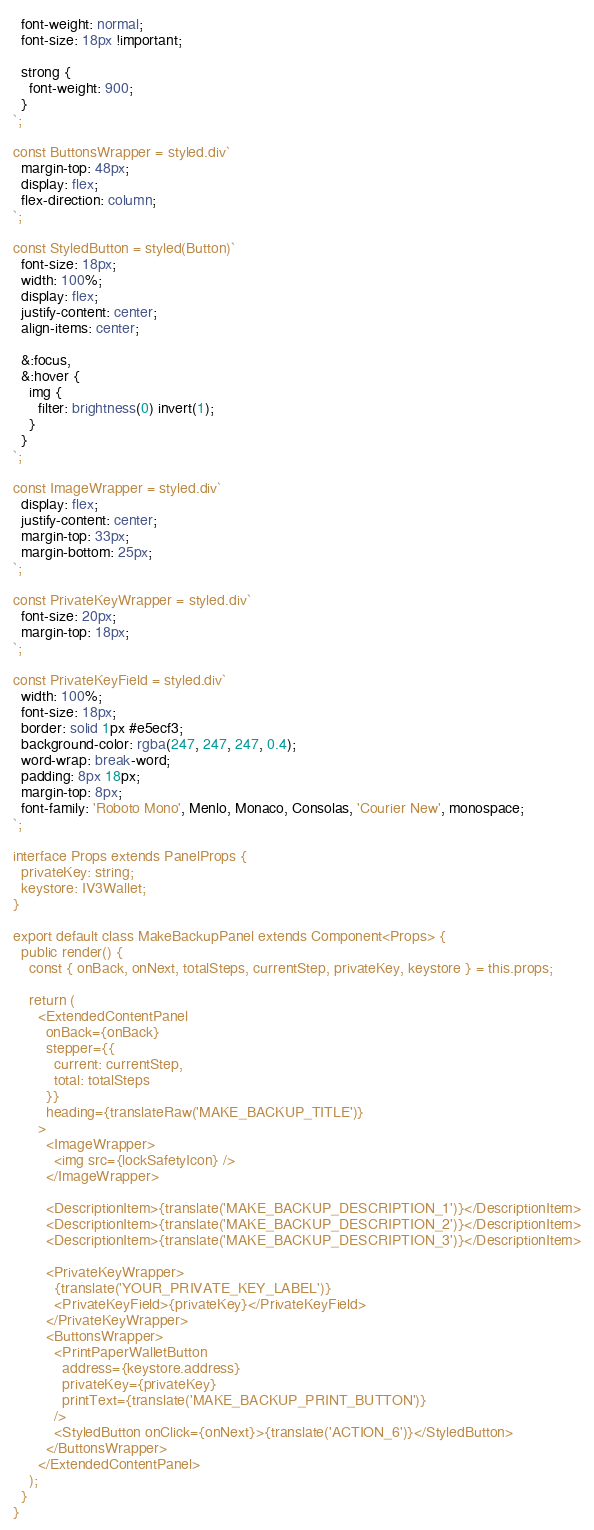Convert code to text. <code><loc_0><loc_0><loc_500><loc_500><_TypeScript_>  font-weight: normal;
  font-size: 18px !important;

  strong {
    font-weight: 900;
  }
`;

const ButtonsWrapper = styled.div`
  margin-top: 48px;
  display: flex;
  flex-direction: column;
`;

const StyledButton = styled(Button)`
  font-size: 18px;
  width: 100%;
  display: flex;
  justify-content: center;
  align-items: center;

  &:focus,
  &:hover {
    img {
      filter: brightness(0) invert(1);
    }
  }
`;

const ImageWrapper = styled.div`
  display: flex;
  justify-content: center;
  margin-top: 33px;
  margin-bottom: 25px;
`;

const PrivateKeyWrapper = styled.div`
  font-size: 20px;
  margin-top: 18px;
`;

const PrivateKeyField = styled.div`
  width: 100%;
  font-size: 18px;
  border: solid 1px #e5ecf3;
  background-color: rgba(247, 247, 247, 0.4);
  word-wrap: break-word;
  padding: 8px 18px;
  margin-top: 8px;
  font-family: 'Roboto Mono', Menlo, Monaco, Consolas, 'Courier New', monospace;
`;

interface Props extends PanelProps {
  privateKey: string;
  keystore: IV3Wallet;
}

export default class MakeBackupPanel extends Component<Props> {
  public render() {
    const { onBack, onNext, totalSteps, currentStep, privateKey, keystore } = this.props;

    return (
      <ExtendedContentPanel
        onBack={onBack}
        stepper={{
          current: currentStep,
          total: totalSteps
        }}
        heading={translateRaw('MAKE_BACKUP_TITLE')}
      >
        <ImageWrapper>
          <img src={lockSafetyIcon} />
        </ImageWrapper>

        <DescriptionItem>{translate('MAKE_BACKUP_DESCRIPTION_1')}</DescriptionItem>
        <DescriptionItem>{translate('MAKE_BACKUP_DESCRIPTION_2')}</DescriptionItem>
        <DescriptionItem>{translate('MAKE_BACKUP_DESCRIPTION_3')}</DescriptionItem>

        <PrivateKeyWrapper>
          {translate('YOUR_PRIVATE_KEY_LABEL')}
          <PrivateKeyField>{privateKey}</PrivateKeyField>
        </PrivateKeyWrapper>
        <ButtonsWrapper>
          <PrintPaperWalletButton
            address={keystore.address}
            privateKey={privateKey}
            printText={translate('MAKE_BACKUP_PRINT_BUTTON')}
          />
          <StyledButton onClick={onNext}>{translate('ACTION_6')}</StyledButton>
        </ButtonsWrapper>
      </ExtendedContentPanel>
    );
  }
}
</code> 